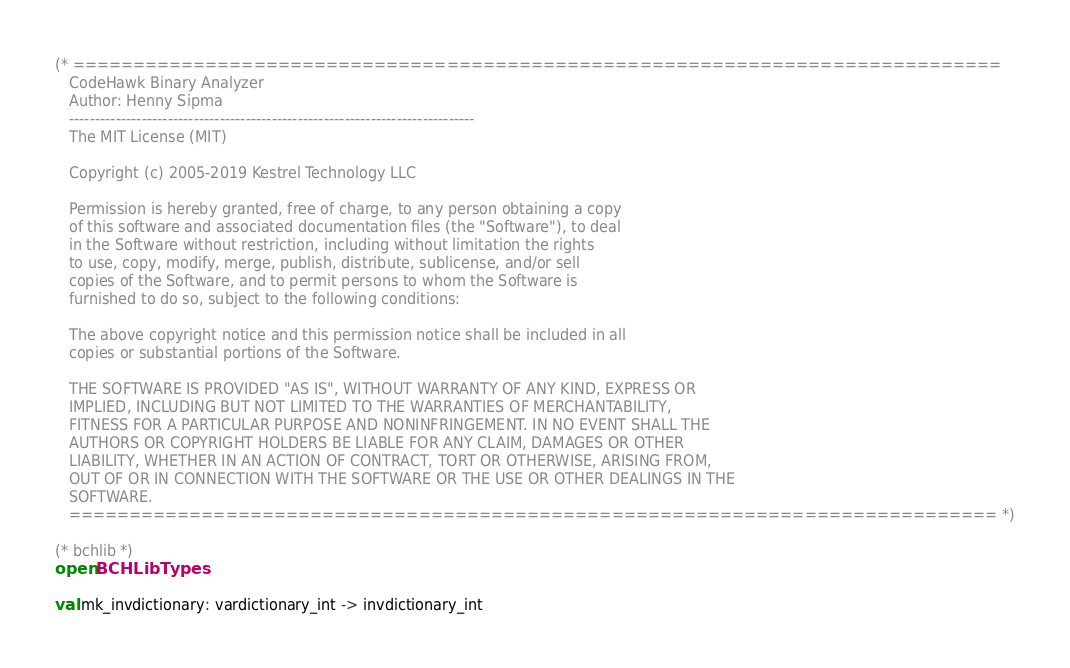<code> <loc_0><loc_0><loc_500><loc_500><_OCaml_>(* =============================================================================
   CodeHawk Binary Analyzer 
   Author: Henny Sipma
   ------------------------------------------------------------------------------
   The MIT License (MIT)
 
   Copyright (c) 2005-2019 Kestrel Technology LLC

   Permission is hereby granted, free of charge, to any person obtaining a copy
   of this software and associated documentation files (the "Software"), to deal
   in the Software without restriction, including without limitation the rights
   to use, copy, modify, merge, publish, distribute, sublicense, and/or sell
   copies of the Software, and to permit persons to whom the Software is
   furnished to do so, subject to the following conditions:
 
   The above copyright notice and this permission notice shall be included in all
   copies or substantial portions of the Software.
  
   THE SOFTWARE IS PROVIDED "AS IS", WITHOUT WARRANTY OF ANY KIND, EXPRESS OR
   IMPLIED, INCLUDING BUT NOT LIMITED TO THE WARRANTIES OF MERCHANTABILITY,
   FITNESS FOR A PARTICULAR PURPOSE AND NONINFRINGEMENT. IN NO EVENT SHALL THE
   AUTHORS OR COPYRIGHT HOLDERS BE LIABLE FOR ANY CLAIM, DAMAGES OR OTHER
   LIABILITY, WHETHER IN AN ACTION OF CONTRACT, TORT OR OTHERWISE, ARISING FROM,
   OUT OF OR IN CONNECTION WITH THE SOFTWARE OR THE USE OR OTHER DEALINGS IN THE
   SOFTWARE.
   ============================================================================= *)

(* bchlib *)
open BCHLibTypes

val mk_invdictionary: vardictionary_int -> invdictionary_int
</code> 